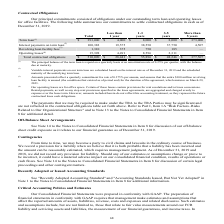According to Greensky's financial document, How was Interest payments on term loan calculated? based on the interest rate as of December 31, 2019 and the scheduled maturity of the underlying term loan.. The document states: "interest payments on our term loan are calculated based on the interest rate as of December 31, 2019 and the scheduled maturity of the underlying term..." Also, What was the company's operating leases for? According to the financial document, office space. The relevant text states: "(4) Our operating leases are for office space. Certain of these leases contain provisions for rent escalations and/or lease concessions. Rental p..." Also, What were the total revolving loan facilities fees? According to the financial document, 1,310 (in thousands). The relevant text states: "550 37,750 4,507 Revolving loan facility fees (3) 1,310 375 750 185 — Operating leases (4) 15,398 4,491 8,596 2,311 — Total contractual obligations $ 510,0..." Also, How many contractual obligations had a total that exceeded $100,000 thousand? Counting the relevant items in the document: Term loan, Interest payments on term loan, I find 2 instances. The key data points involved are: Interest payments on term loan, Term loan. Also, can you calculate: What was the difference in the total between Revolving loan facility fees and operating leases?  Based on the calculation: 15,398-1,310, the result is 14088 (in thousands). This is based on the information: "fees (3) 1,310 375 750 185 — Operating leases (4) 15,398 4,491 8,596 2,311 — Total contractual obligations $ 510,090 $ 28,441 $ 55,896 $ 48,246 $ 377,507 550 37,750 4,507 Revolving loan facility fees ..." The key data points involved are: 1,310, 15,398. Also, can you calculate: What was the contractual obligations due more than 5 years as a percentage of total contractual obligations? Based on the calculation: 377,507/510,090, the result is 74.01 (percentage). This is based on the information: "491 8,596 2,311 — Total contractual obligations $ 510,090 $ 28,441 $ 55,896 $ 48,246 $ 377,507 bligations $ 510,090 $ 28,441 $ 55,896 $ 48,246 $ 377,507..." The key data points involved are: 377,507, 510,090. 